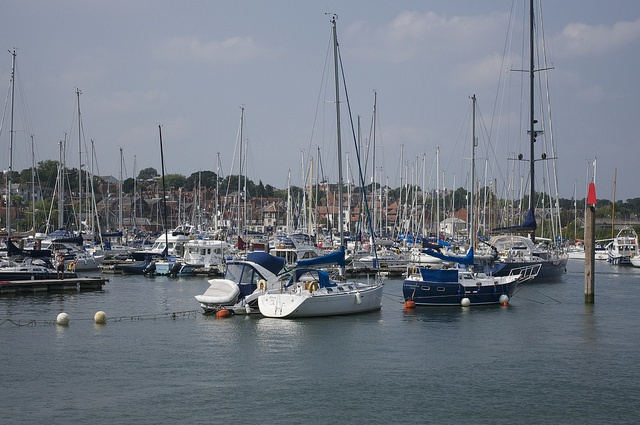Describe the objects in this image and their specific colors. I can see boat in darkgray, black, gray, and lightgray tones, boat in darkgray, black, navy, and gray tones, boat in darkgray, gray, black, and navy tones, boat in darkgray, gray, lightgray, and black tones, and boat in darkgray, gray, black, and navy tones in this image. 